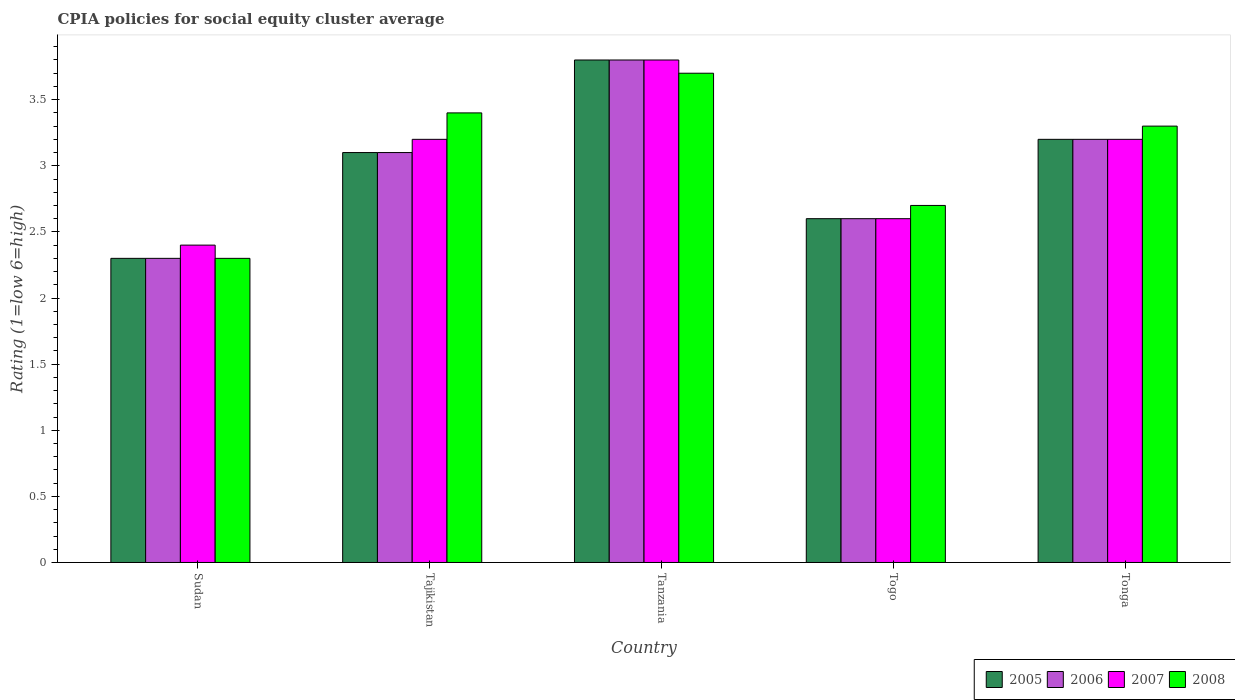How many different coloured bars are there?
Keep it short and to the point. 4. How many groups of bars are there?
Keep it short and to the point. 5. What is the label of the 5th group of bars from the left?
Offer a very short reply. Tonga. In which country was the CPIA rating in 2007 maximum?
Offer a very short reply. Tanzania. In which country was the CPIA rating in 2006 minimum?
Offer a terse response. Sudan. What is the difference between the CPIA rating in 2006 in Tanzania and that in Tonga?
Make the answer very short. 0.6. What is the difference between the CPIA rating in 2008 in Tanzania and the CPIA rating in 2007 in Sudan?
Ensure brevity in your answer.  1.3. What is the average CPIA rating in 2005 per country?
Provide a succinct answer. 3. What is the difference between the CPIA rating of/in 2006 and CPIA rating of/in 2005 in Tonga?
Give a very brief answer. 0. In how many countries, is the CPIA rating in 2008 greater than 2.4?
Your response must be concise. 4. What is the ratio of the CPIA rating in 2007 in Tajikistan to that in Tanzania?
Your response must be concise. 0.84. What is the difference between the highest and the second highest CPIA rating in 2007?
Offer a terse response. -0.6. What is the difference between the highest and the lowest CPIA rating in 2006?
Offer a terse response. 1.5. In how many countries, is the CPIA rating in 2006 greater than the average CPIA rating in 2006 taken over all countries?
Provide a short and direct response. 3. What does the 4th bar from the right in Tonga represents?
Ensure brevity in your answer.  2005. Are the values on the major ticks of Y-axis written in scientific E-notation?
Provide a succinct answer. No. Where does the legend appear in the graph?
Provide a short and direct response. Bottom right. What is the title of the graph?
Your answer should be very brief. CPIA policies for social equity cluster average. Does "1969" appear as one of the legend labels in the graph?
Make the answer very short. No. What is the label or title of the X-axis?
Provide a succinct answer. Country. What is the label or title of the Y-axis?
Offer a very short reply. Rating (1=low 6=high). What is the Rating (1=low 6=high) of 2006 in Sudan?
Keep it short and to the point. 2.3. What is the Rating (1=low 6=high) in 2007 in Sudan?
Ensure brevity in your answer.  2.4. What is the Rating (1=low 6=high) in 2008 in Sudan?
Keep it short and to the point. 2.3. What is the Rating (1=low 6=high) of 2006 in Tajikistan?
Your answer should be very brief. 3.1. What is the Rating (1=low 6=high) in 2007 in Tajikistan?
Your answer should be compact. 3.2. What is the Rating (1=low 6=high) of 2008 in Tajikistan?
Provide a succinct answer. 3.4. What is the Rating (1=low 6=high) in 2005 in Tanzania?
Provide a short and direct response. 3.8. What is the Rating (1=low 6=high) of 2006 in Tanzania?
Keep it short and to the point. 3.8. What is the Rating (1=low 6=high) in 2007 in Tanzania?
Provide a succinct answer. 3.8. What is the Rating (1=low 6=high) in 2005 in Tonga?
Keep it short and to the point. 3.2. What is the Rating (1=low 6=high) of 2006 in Tonga?
Give a very brief answer. 3.2. What is the Rating (1=low 6=high) of 2008 in Tonga?
Your response must be concise. 3.3. Across all countries, what is the maximum Rating (1=low 6=high) in 2006?
Your answer should be very brief. 3.8. Across all countries, what is the maximum Rating (1=low 6=high) of 2008?
Give a very brief answer. 3.7. Across all countries, what is the minimum Rating (1=low 6=high) of 2008?
Ensure brevity in your answer.  2.3. What is the difference between the Rating (1=low 6=high) in 2005 in Sudan and that in Tajikistan?
Your answer should be compact. -0.8. What is the difference between the Rating (1=low 6=high) of 2007 in Sudan and that in Tajikistan?
Provide a short and direct response. -0.8. What is the difference between the Rating (1=low 6=high) in 2008 in Sudan and that in Tajikistan?
Provide a short and direct response. -1.1. What is the difference between the Rating (1=low 6=high) in 2005 in Sudan and that in Tanzania?
Your response must be concise. -1.5. What is the difference between the Rating (1=low 6=high) of 2008 in Sudan and that in Tanzania?
Offer a very short reply. -1.4. What is the difference between the Rating (1=low 6=high) in 2005 in Sudan and that in Togo?
Ensure brevity in your answer.  -0.3. What is the difference between the Rating (1=low 6=high) in 2008 in Sudan and that in Togo?
Your answer should be very brief. -0.4. What is the difference between the Rating (1=low 6=high) of 2005 in Sudan and that in Tonga?
Your answer should be very brief. -0.9. What is the difference between the Rating (1=low 6=high) in 2006 in Sudan and that in Tonga?
Make the answer very short. -0.9. What is the difference between the Rating (1=low 6=high) in 2007 in Sudan and that in Tonga?
Your answer should be very brief. -0.8. What is the difference between the Rating (1=low 6=high) in 2008 in Sudan and that in Tonga?
Provide a short and direct response. -1. What is the difference between the Rating (1=low 6=high) in 2007 in Tajikistan and that in Tanzania?
Ensure brevity in your answer.  -0.6. What is the difference between the Rating (1=low 6=high) of 2008 in Tajikistan and that in Tanzania?
Your response must be concise. -0.3. What is the difference between the Rating (1=low 6=high) in 2008 in Tajikistan and that in Togo?
Your answer should be compact. 0.7. What is the difference between the Rating (1=low 6=high) of 2006 in Tajikistan and that in Tonga?
Offer a very short reply. -0.1. What is the difference between the Rating (1=low 6=high) in 2007 in Tajikistan and that in Tonga?
Ensure brevity in your answer.  0. What is the difference between the Rating (1=low 6=high) of 2005 in Tanzania and that in Togo?
Your response must be concise. 1.2. What is the difference between the Rating (1=low 6=high) of 2007 in Tanzania and that in Togo?
Keep it short and to the point. 1.2. What is the difference between the Rating (1=low 6=high) in 2006 in Tanzania and that in Tonga?
Provide a short and direct response. 0.6. What is the difference between the Rating (1=low 6=high) in 2008 in Tanzania and that in Tonga?
Your answer should be very brief. 0.4. What is the difference between the Rating (1=low 6=high) in 2006 in Togo and that in Tonga?
Make the answer very short. -0.6. What is the difference between the Rating (1=low 6=high) of 2007 in Togo and that in Tonga?
Keep it short and to the point. -0.6. What is the difference between the Rating (1=low 6=high) of 2005 in Sudan and the Rating (1=low 6=high) of 2006 in Tanzania?
Offer a very short reply. -1.5. What is the difference between the Rating (1=low 6=high) of 2005 in Sudan and the Rating (1=low 6=high) of 2008 in Tanzania?
Provide a succinct answer. -1.4. What is the difference between the Rating (1=low 6=high) of 2006 in Sudan and the Rating (1=low 6=high) of 2008 in Tanzania?
Ensure brevity in your answer.  -1.4. What is the difference between the Rating (1=low 6=high) in 2005 in Sudan and the Rating (1=low 6=high) in 2008 in Togo?
Offer a very short reply. -0.4. What is the difference between the Rating (1=low 6=high) of 2006 in Sudan and the Rating (1=low 6=high) of 2007 in Togo?
Provide a short and direct response. -0.3. What is the difference between the Rating (1=low 6=high) in 2007 in Sudan and the Rating (1=low 6=high) in 2008 in Togo?
Your response must be concise. -0.3. What is the difference between the Rating (1=low 6=high) in 2005 in Sudan and the Rating (1=low 6=high) in 2006 in Tonga?
Provide a short and direct response. -0.9. What is the difference between the Rating (1=low 6=high) of 2006 in Sudan and the Rating (1=low 6=high) of 2007 in Tonga?
Provide a succinct answer. -0.9. What is the difference between the Rating (1=low 6=high) in 2007 in Sudan and the Rating (1=low 6=high) in 2008 in Tonga?
Make the answer very short. -0.9. What is the difference between the Rating (1=low 6=high) of 2005 in Tajikistan and the Rating (1=low 6=high) of 2007 in Tanzania?
Your answer should be compact. -0.7. What is the difference between the Rating (1=low 6=high) in 2007 in Tajikistan and the Rating (1=low 6=high) in 2008 in Tanzania?
Your answer should be compact. -0.5. What is the difference between the Rating (1=low 6=high) of 2005 in Tajikistan and the Rating (1=low 6=high) of 2006 in Togo?
Ensure brevity in your answer.  0.5. What is the difference between the Rating (1=low 6=high) of 2006 in Tajikistan and the Rating (1=low 6=high) of 2007 in Togo?
Your answer should be compact. 0.5. What is the difference between the Rating (1=low 6=high) of 2006 in Tajikistan and the Rating (1=low 6=high) of 2008 in Togo?
Offer a very short reply. 0.4. What is the difference between the Rating (1=low 6=high) in 2005 in Tajikistan and the Rating (1=low 6=high) in 2006 in Tonga?
Your response must be concise. -0.1. What is the difference between the Rating (1=low 6=high) in 2005 in Tajikistan and the Rating (1=low 6=high) in 2007 in Tonga?
Your response must be concise. -0.1. What is the difference between the Rating (1=low 6=high) in 2006 in Tajikistan and the Rating (1=low 6=high) in 2007 in Tonga?
Provide a short and direct response. -0.1. What is the difference between the Rating (1=low 6=high) in 2007 in Tajikistan and the Rating (1=low 6=high) in 2008 in Tonga?
Give a very brief answer. -0.1. What is the difference between the Rating (1=low 6=high) in 2005 in Tanzania and the Rating (1=low 6=high) in 2006 in Togo?
Your response must be concise. 1.2. What is the difference between the Rating (1=low 6=high) in 2005 in Tanzania and the Rating (1=low 6=high) in 2008 in Togo?
Give a very brief answer. 1.1. What is the difference between the Rating (1=low 6=high) of 2006 in Tanzania and the Rating (1=low 6=high) of 2007 in Togo?
Make the answer very short. 1.2. What is the difference between the Rating (1=low 6=high) of 2006 in Tanzania and the Rating (1=low 6=high) of 2008 in Togo?
Make the answer very short. 1.1. What is the difference between the Rating (1=low 6=high) in 2005 in Tanzania and the Rating (1=low 6=high) in 2006 in Tonga?
Offer a terse response. 0.6. What is the difference between the Rating (1=low 6=high) of 2005 in Tanzania and the Rating (1=low 6=high) of 2007 in Tonga?
Offer a terse response. 0.6. What is the difference between the Rating (1=low 6=high) of 2005 in Tanzania and the Rating (1=low 6=high) of 2008 in Tonga?
Offer a terse response. 0.5. What is the difference between the Rating (1=low 6=high) in 2006 in Tanzania and the Rating (1=low 6=high) in 2007 in Tonga?
Offer a very short reply. 0.6. What is the difference between the Rating (1=low 6=high) of 2007 in Tanzania and the Rating (1=low 6=high) of 2008 in Tonga?
Offer a very short reply. 0.5. What is the difference between the Rating (1=low 6=high) of 2005 in Togo and the Rating (1=low 6=high) of 2007 in Tonga?
Make the answer very short. -0.6. What is the difference between the Rating (1=low 6=high) of 2007 in Togo and the Rating (1=low 6=high) of 2008 in Tonga?
Your answer should be compact. -0.7. What is the average Rating (1=low 6=high) of 2005 per country?
Offer a very short reply. 3. What is the average Rating (1=low 6=high) of 2006 per country?
Provide a succinct answer. 3. What is the average Rating (1=low 6=high) of 2007 per country?
Your answer should be very brief. 3.04. What is the average Rating (1=low 6=high) in 2008 per country?
Your answer should be compact. 3.08. What is the difference between the Rating (1=low 6=high) of 2005 and Rating (1=low 6=high) of 2008 in Sudan?
Provide a succinct answer. 0. What is the difference between the Rating (1=low 6=high) in 2006 and Rating (1=low 6=high) in 2007 in Sudan?
Your answer should be compact. -0.1. What is the difference between the Rating (1=low 6=high) of 2006 and Rating (1=low 6=high) of 2008 in Sudan?
Offer a terse response. 0. What is the difference between the Rating (1=low 6=high) in 2005 and Rating (1=low 6=high) in 2008 in Tajikistan?
Ensure brevity in your answer.  -0.3. What is the difference between the Rating (1=low 6=high) of 2006 and Rating (1=low 6=high) of 2007 in Tajikistan?
Provide a short and direct response. -0.1. What is the difference between the Rating (1=low 6=high) of 2006 and Rating (1=low 6=high) of 2008 in Tajikistan?
Your answer should be very brief. -0.3. What is the difference between the Rating (1=low 6=high) in 2005 and Rating (1=low 6=high) in 2006 in Tanzania?
Give a very brief answer. 0. What is the difference between the Rating (1=low 6=high) of 2006 and Rating (1=low 6=high) of 2007 in Tanzania?
Ensure brevity in your answer.  0. What is the difference between the Rating (1=low 6=high) in 2006 and Rating (1=low 6=high) in 2008 in Tanzania?
Provide a succinct answer. 0.1. What is the difference between the Rating (1=low 6=high) of 2005 and Rating (1=low 6=high) of 2006 in Togo?
Provide a succinct answer. 0. What is the difference between the Rating (1=low 6=high) of 2006 and Rating (1=low 6=high) of 2008 in Togo?
Offer a terse response. -0.1. What is the difference between the Rating (1=low 6=high) of 2005 and Rating (1=low 6=high) of 2006 in Tonga?
Keep it short and to the point. 0. What is the difference between the Rating (1=low 6=high) in 2005 and Rating (1=low 6=high) in 2007 in Tonga?
Provide a succinct answer. 0. What is the ratio of the Rating (1=low 6=high) of 2005 in Sudan to that in Tajikistan?
Offer a very short reply. 0.74. What is the ratio of the Rating (1=low 6=high) of 2006 in Sudan to that in Tajikistan?
Ensure brevity in your answer.  0.74. What is the ratio of the Rating (1=low 6=high) in 2007 in Sudan to that in Tajikistan?
Offer a very short reply. 0.75. What is the ratio of the Rating (1=low 6=high) of 2008 in Sudan to that in Tajikistan?
Offer a very short reply. 0.68. What is the ratio of the Rating (1=low 6=high) of 2005 in Sudan to that in Tanzania?
Your answer should be compact. 0.61. What is the ratio of the Rating (1=low 6=high) of 2006 in Sudan to that in Tanzania?
Make the answer very short. 0.61. What is the ratio of the Rating (1=low 6=high) of 2007 in Sudan to that in Tanzania?
Your answer should be compact. 0.63. What is the ratio of the Rating (1=low 6=high) of 2008 in Sudan to that in Tanzania?
Make the answer very short. 0.62. What is the ratio of the Rating (1=low 6=high) in 2005 in Sudan to that in Togo?
Your answer should be compact. 0.88. What is the ratio of the Rating (1=low 6=high) of 2006 in Sudan to that in Togo?
Ensure brevity in your answer.  0.88. What is the ratio of the Rating (1=low 6=high) of 2007 in Sudan to that in Togo?
Keep it short and to the point. 0.92. What is the ratio of the Rating (1=low 6=high) of 2008 in Sudan to that in Togo?
Offer a terse response. 0.85. What is the ratio of the Rating (1=low 6=high) in 2005 in Sudan to that in Tonga?
Offer a very short reply. 0.72. What is the ratio of the Rating (1=low 6=high) in 2006 in Sudan to that in Tonga?
Give a very brief answer. 0.72. What is the ratio of the Rating (1=low 6=high) of 2007 in Sudan to that in Tonga?
Offer a very short reply. 0.75. What is the ratio of the Rating (1=low 6=high) of 2008 in Sudan to that in Tonga?
Provide a short and direct response. 0.7. What is the ratio of the Rating (1=low 6=high) of 2005 in Tajikistan to that in Tanzania?
Provide a short and direct response. 0.82. What is the ratio of the Rating (1=low 6=high) of 2006 in Tajikistan to that in Tanzania?
Ensure brevity in your answer.  0.82. What is the ratio of the Rating (1=low 6=high) of 2007 in Tajikistan to that in Tanzania?
Ensure brevity in your answer.  0.84. What is the ratio of the Rating (1=low 6=high) in 2008 in Tajikistan to that in Tanzania?
Keep it short and to the point. 0.92. What is the ratio of the Rating (1=low 6=high) in 2005 in Tajikistan to that in Togo?
Ensure brevity in your answer.  1.19. What is the ratio of the Rating (1=low 6=high) in 2006 in Tajikistan to that in Togo?
Provide a succinct answer. 1.19. What is the ratio of the Rating (1=low 6=high) in 2007 in Tajikistan to that in Togo?
Keep it short and to the point. 1.23. What is the ratio of the Rating (1=low 6=high) of 2008 in Tajikistan to that in Togo?
Keep it short and to the point. 1.26. What is the ratio of the Rating (1=low 6=high) in 2005 in Tajikistan to that in Tonga?
Provide a short and direct response. 0.97. What is the ratio of the Rating (1=low 6=high) of 2006 in Tajikistan to that in Tonga?
Provide a succinct answer. 0.97. What is the ratio of the Rating (1=low 6=high) in 2007 in Tajikistan to that in Tonga?
Your response must be concise. 1. What is the ratio of the Rating (1=low 6=high) in 2008 in Tajikistan to that in Tonga?
Ensure brevity in your answer.  1.03. What is the ratio of the Rating (1=low 6=high) in 2005 in Tanzania to that in Togo?
Offer a terse response. 1.46. What is the ratio of the Rating (1=low 6=high) in 2006 in Tanzania to that in Togo?
Make the answer very short. 1.46. What is the ratio of the Rating (1=low 6=high) of 2007 in Tanzania to that in Togo?
Give a very brief answer. 1.46. What is the ratio of the Rating (1=low 6=high) of 2008 in Tanzania to that in Togo?
Offer a terse response. 1.37. What is the ratio of the Rating (1=low 6=high) in 2005 in Tanzania to that in Tonga?
Your response must be concise. 1.19. What is the ratio of the Rating (1=low 6=high) in 2006 in Tanzania to that in Tonga?
Your response must be concise. 1.19. What is the ratio of the Rating (1=low 6=high) in 2007 in Tanzania to that in Tonga?
Keep it short and to the point. 1.19. What is the ratio of the Rating (1=low 6=high) of 2008 in Tanzania to that in Tonga?
Offer a very short reply. 1.12. What is the ratio of the Rating (1=low 6=high) of 2005 in Togo to that in Tonga?
Your response must be concise. 0.81. What is the ratio of the Rating (1=low 6=high) in 2006 in Togo to that in Tonga?
Your response must be concise. 0.81. What is the ratio of the Rating (1=low 6=high) of 2007 in Togo to that in Tonga?
Provide a succinct answer. 0.81. What is the ratio of the Rating (1=low 6=high) in 2008 in Togo to that in Tonga?
Ensure brevity in your answer.  0.82. What is the difference between the highest and the second highest Rating (1=low 6=high) of 2005?
Ensure brevity in your answer.  0.6. What is the difference between the highest and the second highest Rating (1=low 6=high) of 2006?
Your answer should be very brief. 0.6. What is the difference between the highest and the second highest Rating (1=low 6=high) of 2008?
Keep it short and to the point. 0.3. What is the difference between the highest and the lowest Rating (1=low 6=high) of 2006?
Your response must be concise. 1.5. What is the difference between the highest and the lowest Rating (1=low 6=high) in 2007?
Provide a succinct answer. 1.4. What is the difference between the highest and the lowest Rating (1=low 6=high) in 2008?
Give a very brief answer. 1.4. 